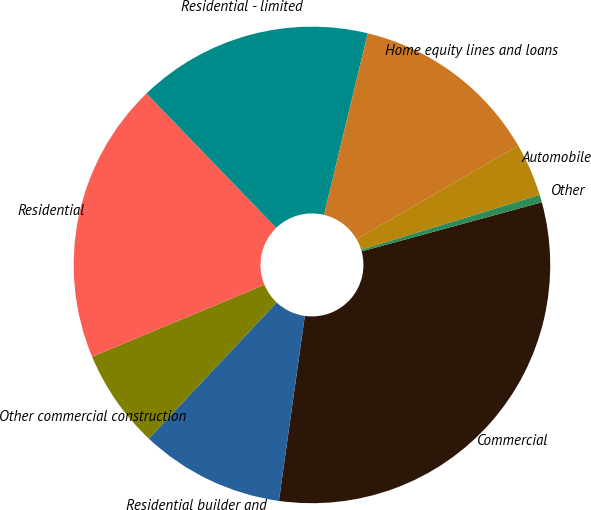Convert chart to OTSL. <chart><loc_0><loc_0><loc_500><loc_500><pie_chart><fcel>Commercial<fcel>Residential builder and<fcel>Other commercial construction<fcel>Residential<fcel>Residential - limited<fcel>Home equity lines and loans<fcel>Automobile<fcel>Other<nl><fcel>31.45%<fcel>9.79%<fcel>6.7%<fcel>19.08%<fcel>15.98%<fcel>12.89%<fcel>3.6%<fcel>0.51%<nl></chart> 